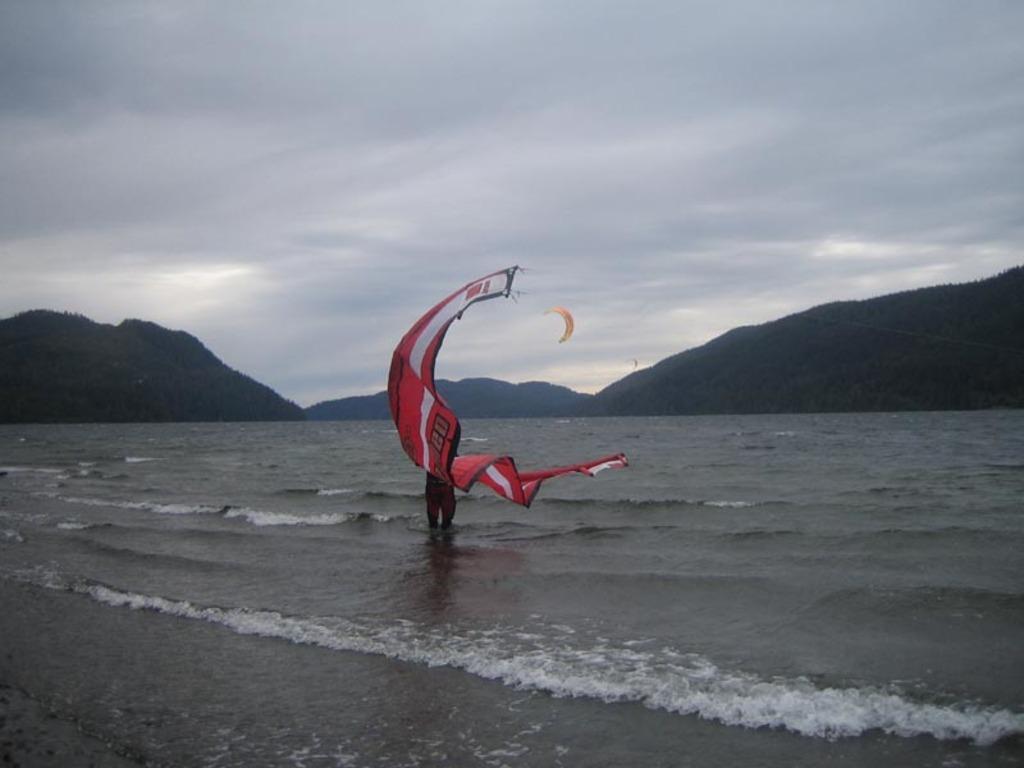How would you summarize this image in a sentence or two? This is the picture of a person who is holding the parachute and standing in the water and behind there are some mountains. 